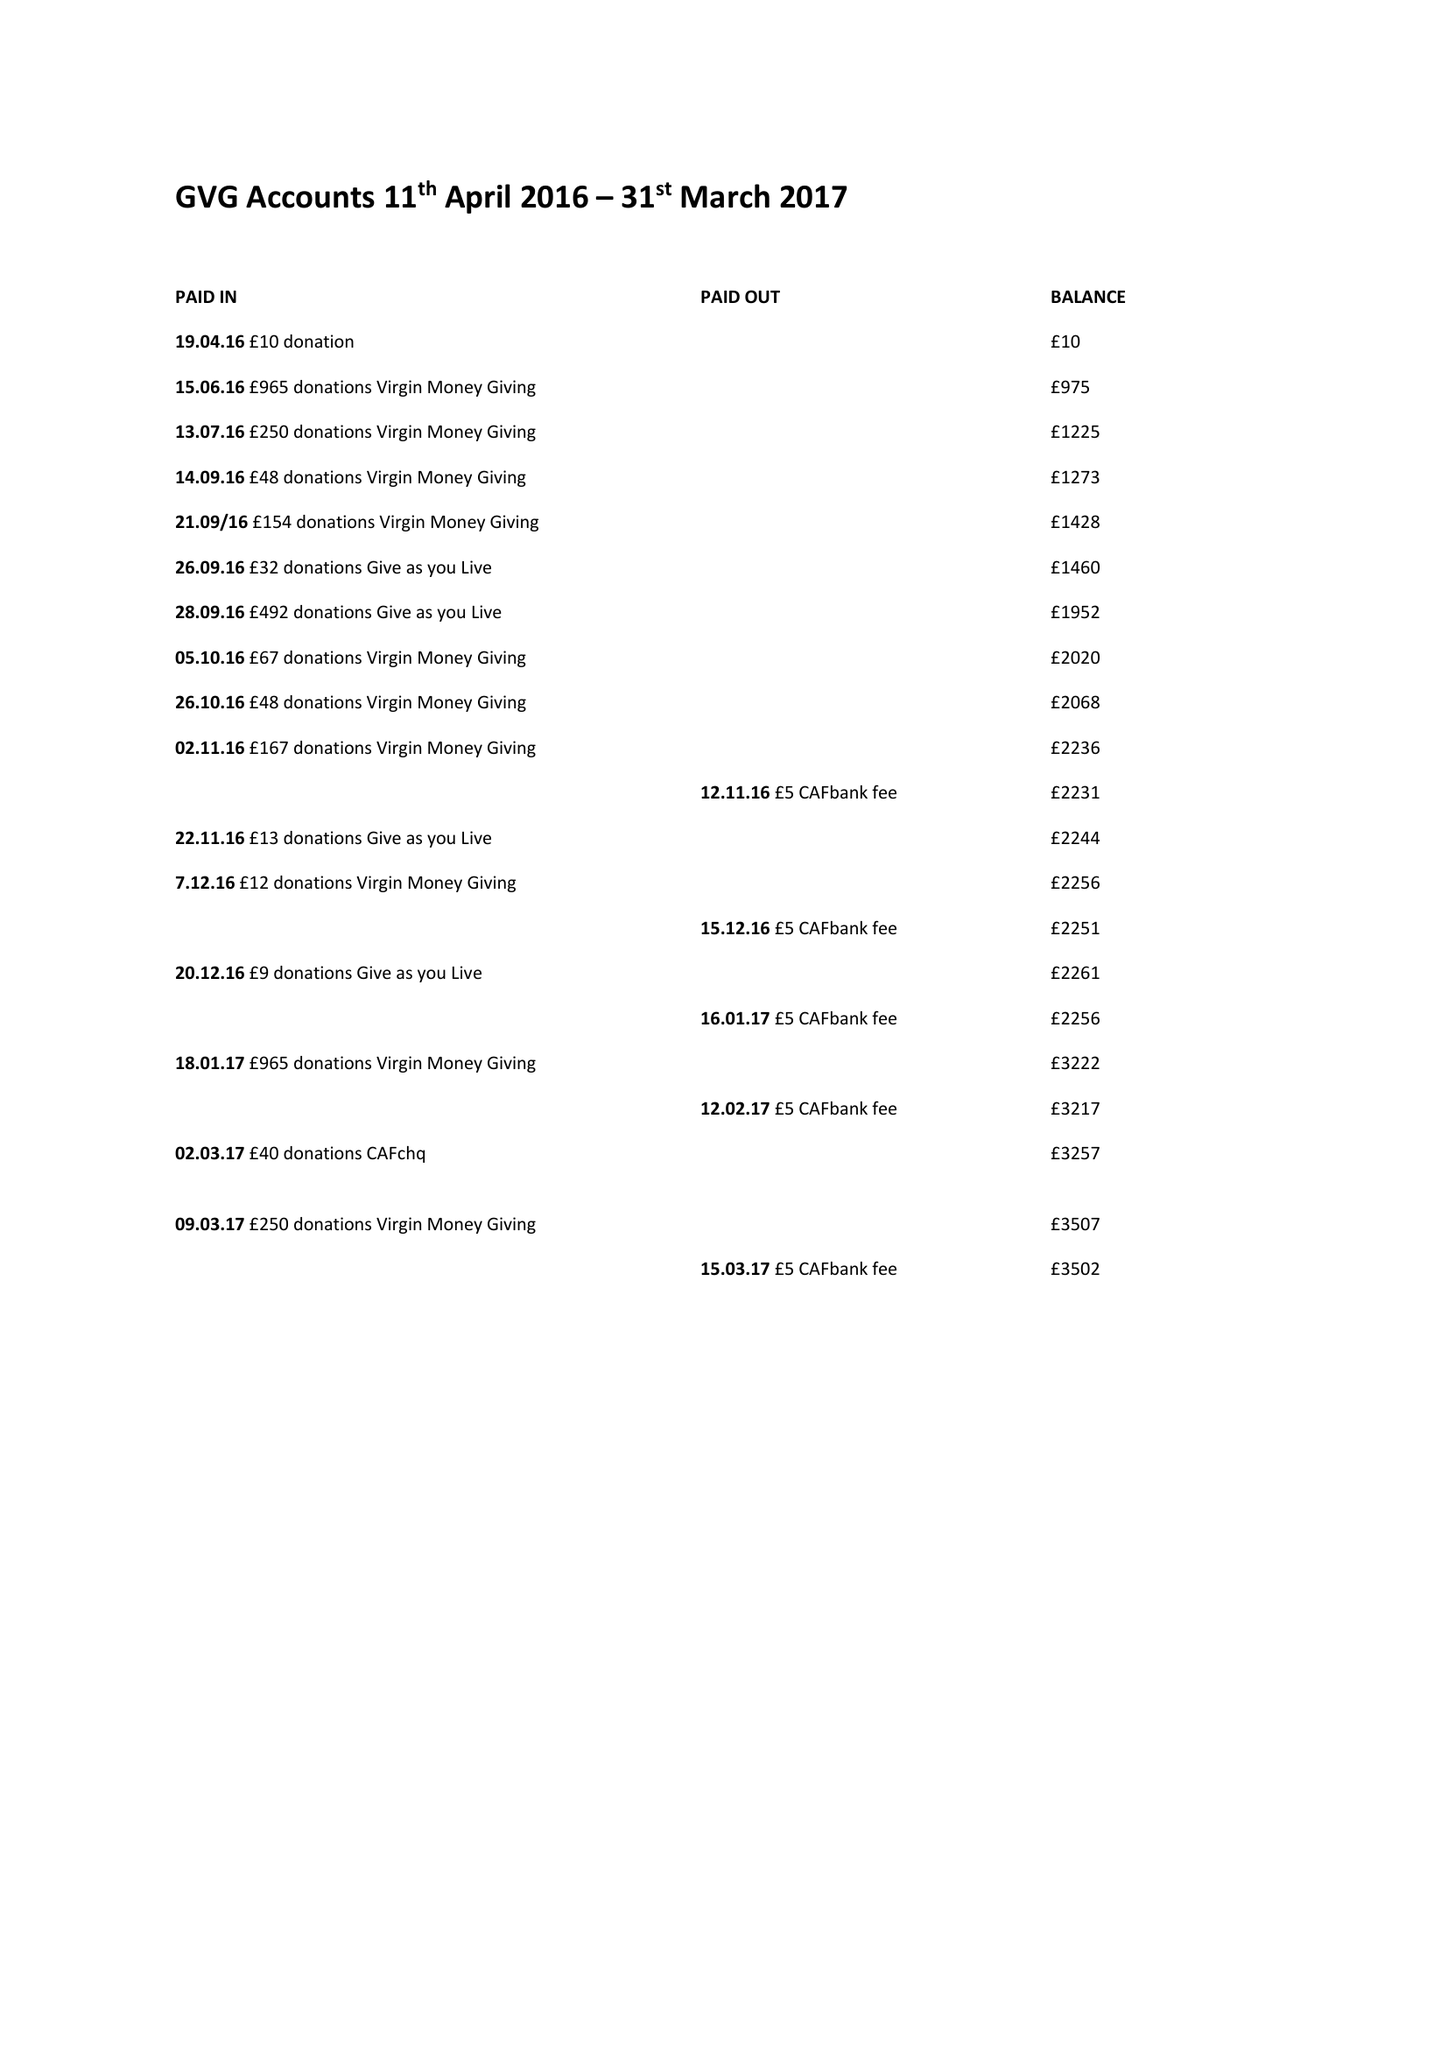What is the value for the charity_name?
Answer the question using a single word or phrase. Good Vibrations Giving 